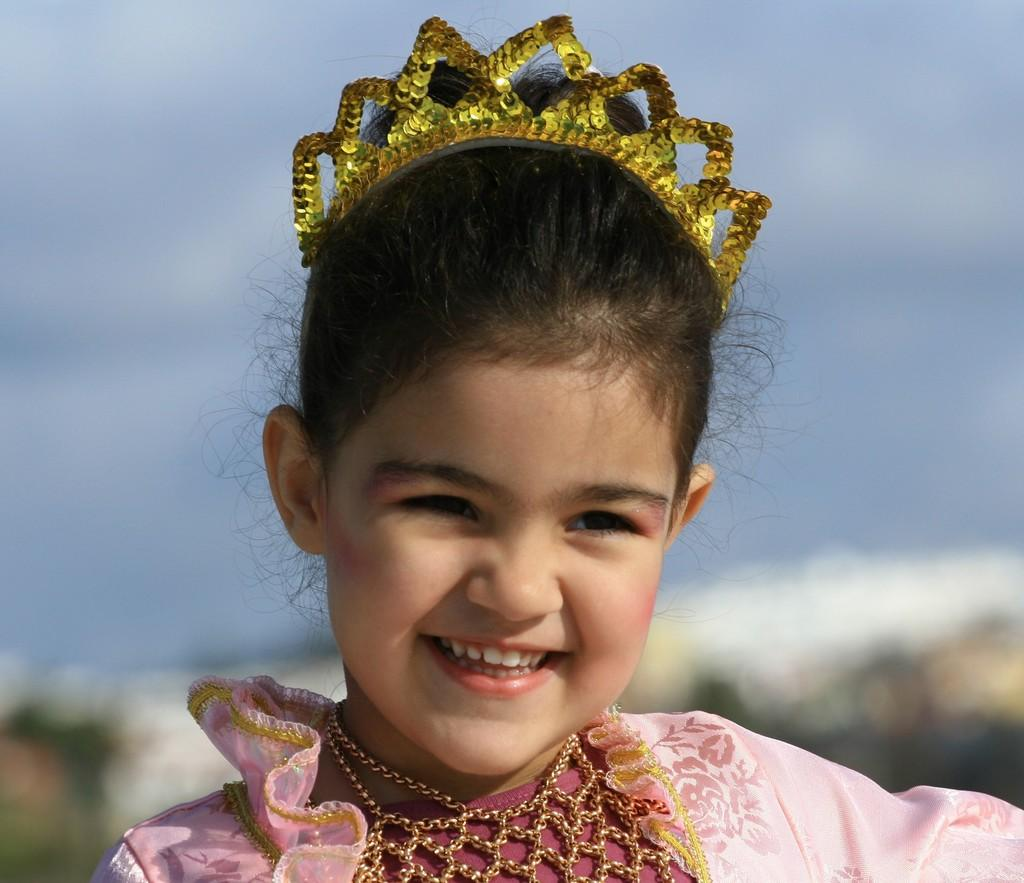Who is present in the image? There is a girl in the image. What is the girl's expression in the image? The girl is smiling in the image. What can be seen in the background of the image? There is sky visible in the background of the image. What type of snail can be seen crawling on the girl's shoulder in the image? There is no snail present on the girl's shoulder in the image. Is the girl holding a basketball in the image? There is no basketball visible in the image. 